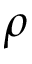Convert formula to latex. <formula><loc_0><loc_0><loc_500><loc_500>\rho</formula> 